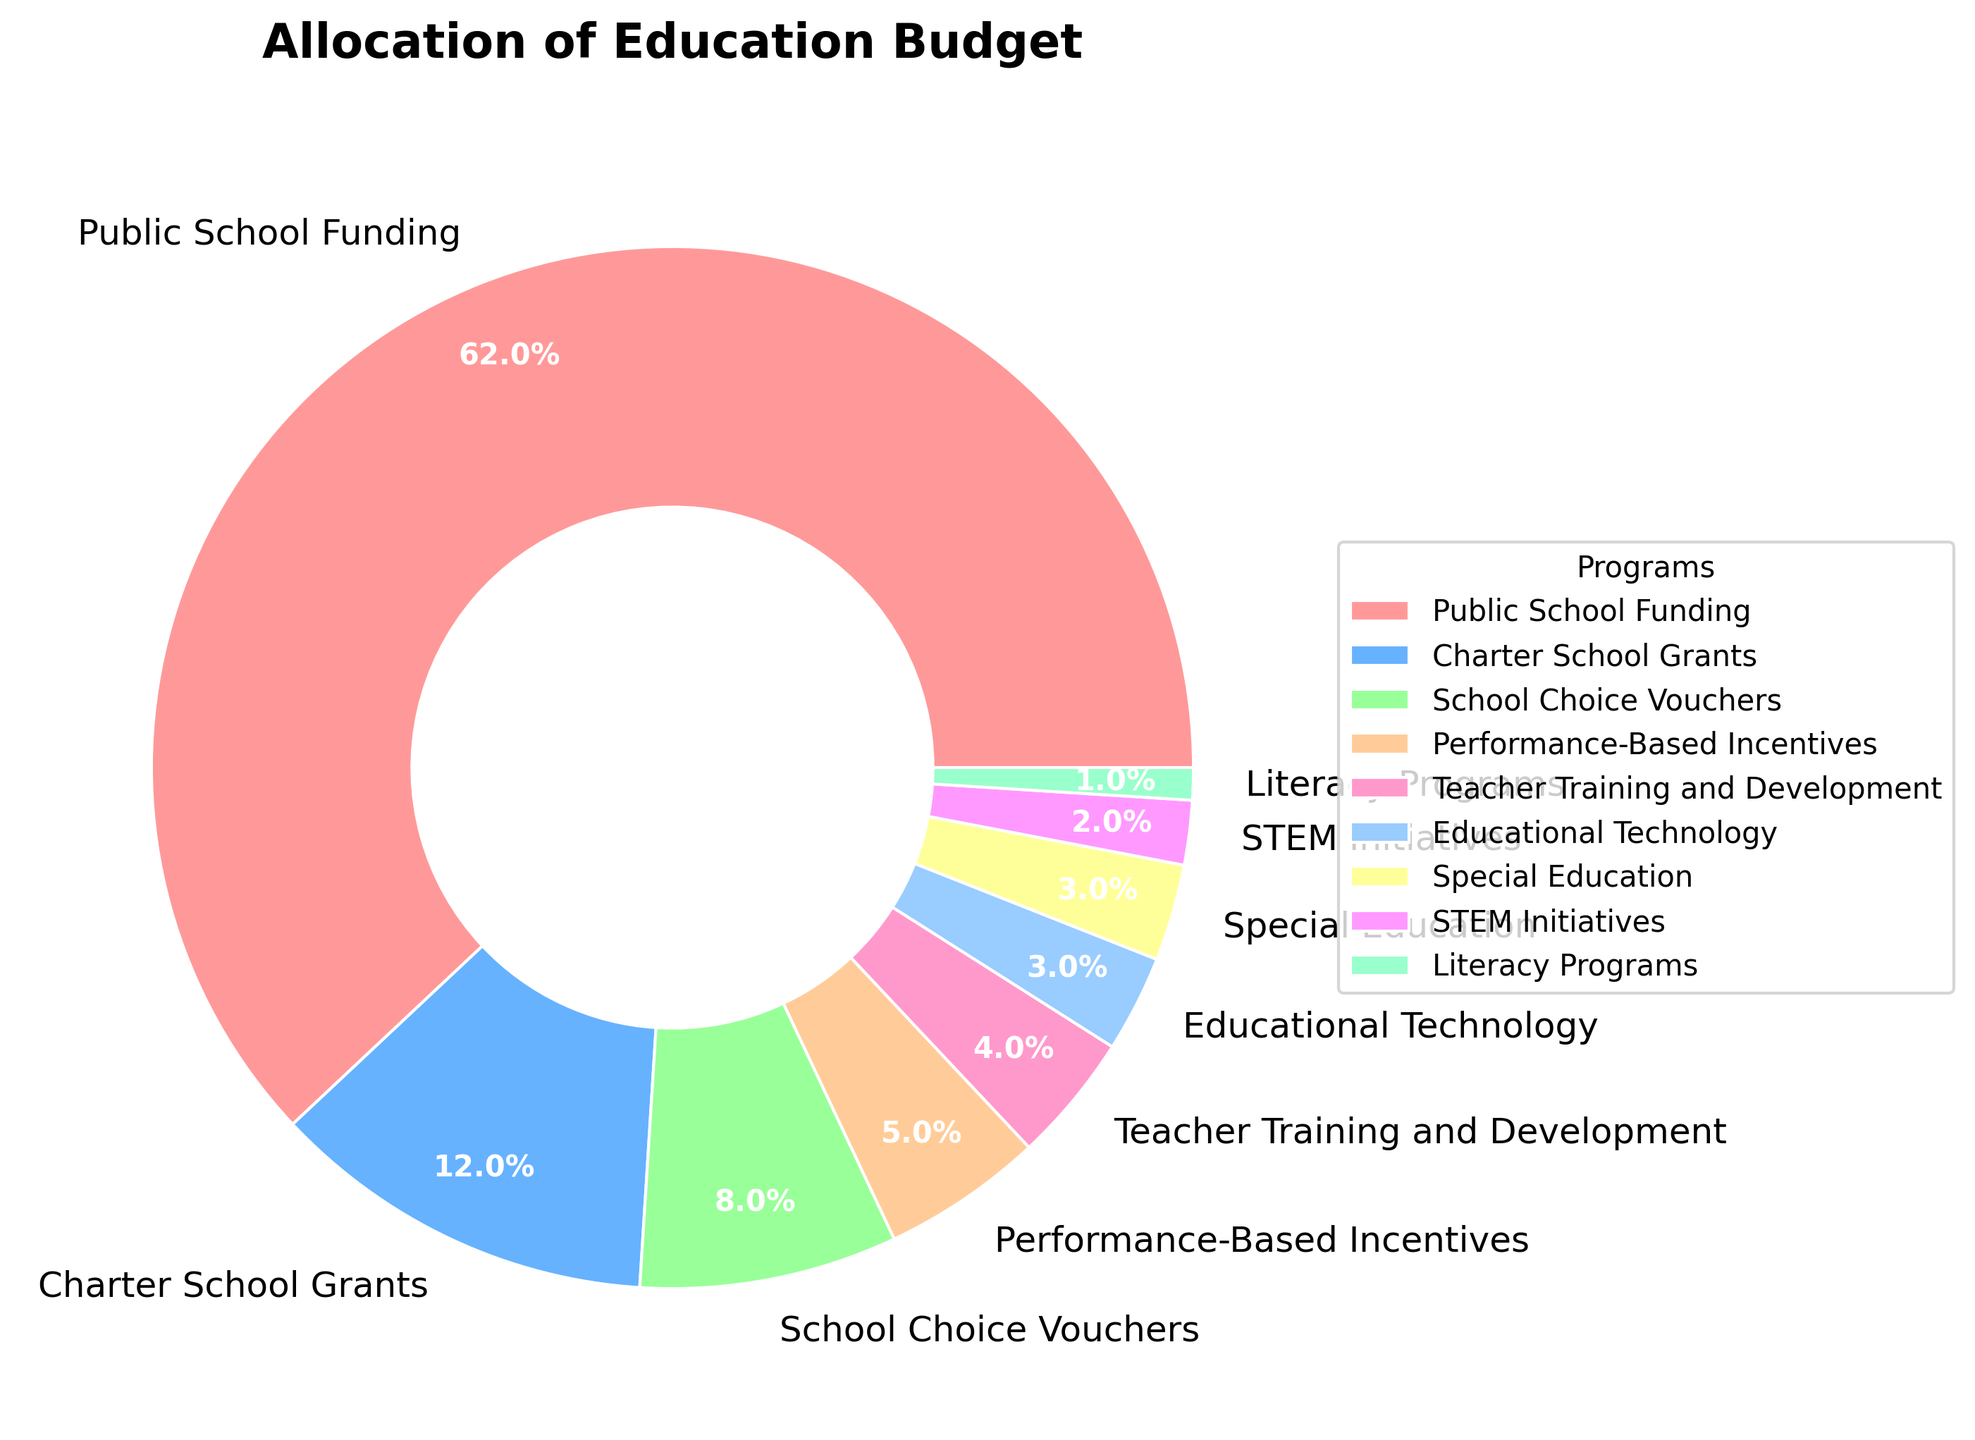What's the total percentage allocated to Public School Funding and Charter School Grants? To find the total percentage allocated to Public School Funding and Charter School Grants, sum their percentages. Public School Funding is 62%, and Charter School Grants is 12%. Therefore, the total is 62% + 12% = 74%.
Answer: 74% Which program receives a smaller budget allocation: School Choice Vouchers or Educational Technology? Compare the percentages allocated to School Choice Vouchers and Educational Technology. School Choice Vouchers receive 8%, while Educational Technology receives 3%. Therefore, Educational Technology receives a smaller budget allocation.
Answer: Educational Technology What is the largest budget allocation in the pie chart, and which program does it represent? The largest budget allocation can be identified as the section with the biggest wedge in the pie chart. The Public School Funding program has the largest allocation, which is 62%.
Answer: Public School Funding (62%) What's the combined budget allocation for Performance-Based Incentives, Teacher Training and Development, and Special Education? To find the combined budget allocation, sum the percentages of Performance-Based Incentives, Teacher Training and Development, and Special Education. The values are 5%, 4%, and 3% respectively, so the total is 5% + 4% + 3% = 12%.
Answer: 12% Which section of the pie chart is the smallest, and what percentage does it represent? The smallest section of the pie chart can be identified visually. Literacy Programs have the smallest wedge, representing 1%.
Answer: Literacy Programs (1%) Compare the allocation to STEM Initiatives and Literacy Programs. Which one is higher, and by how much? STEM Initiatives receive 2%, whereas Literacy Programs receive only 1%. Therefore, STEM Initiatives get 1% more than Literacy Programs.
Answer: STEM Initiatives by 1% How does the allocation to Teacher Training and Development compare to Special Education? Teacher Training and Development is allocated 4%, while Special Education is allocated 3%. Hence, Teacher Training and Development has a higher allocation by 1%.
Answer: Teacher Training and Development by 1% What's the average allocation percentage across all the programs listed? Sum all percentages and divide by the total number of programs. (62% + 12% + 8% + 5% + 4% + 3% + 3% + 2% + 1%) / 9 = 100% / 9 ≈ 11.1%.
Answer: 11.1% What is the total allocation percentage for the programs receiving less than 5% each? Identify and sum the percentages for programs receiving less than 5%: Performance-Based Incentives (5%), Teacher Training and Development (4%), Educational Technology (3%), Special Education (3%), STEM Initiatives (2%), and Literacy Programs (1%). However, Performance-Based Incentives is exactly 5%, so not included. So, 4% + 3% + 3% + 2% + 1% = 13%.
Answer: 13% 